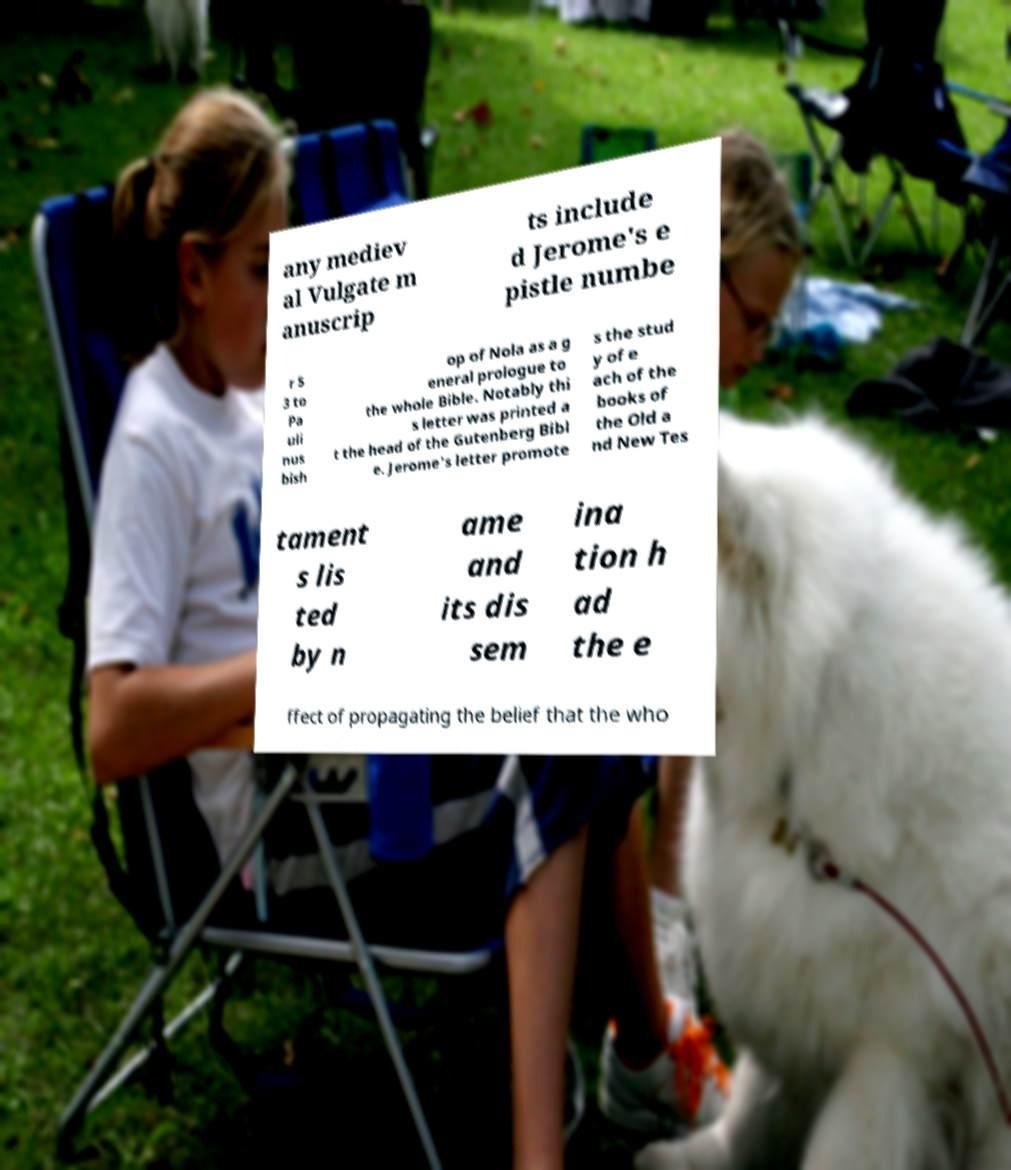Please identify and transcribe the text found in this image. any mediev al Vulgate m anuscrip ts include d Jerome's e pistle numbe r 5 3 to Pa uli nus bish op of Nola as a g eneral prologue to the whole Bible. Notably thi s letter was printed a t the head of the Gutenberg Bibl e. Jerome's letter promote s the stud y of e ach of the books of the Old a nd New Tes tament s lis ted by n ame and its dis sem ina tion h ad the e ffect of propagating the belief that the who 